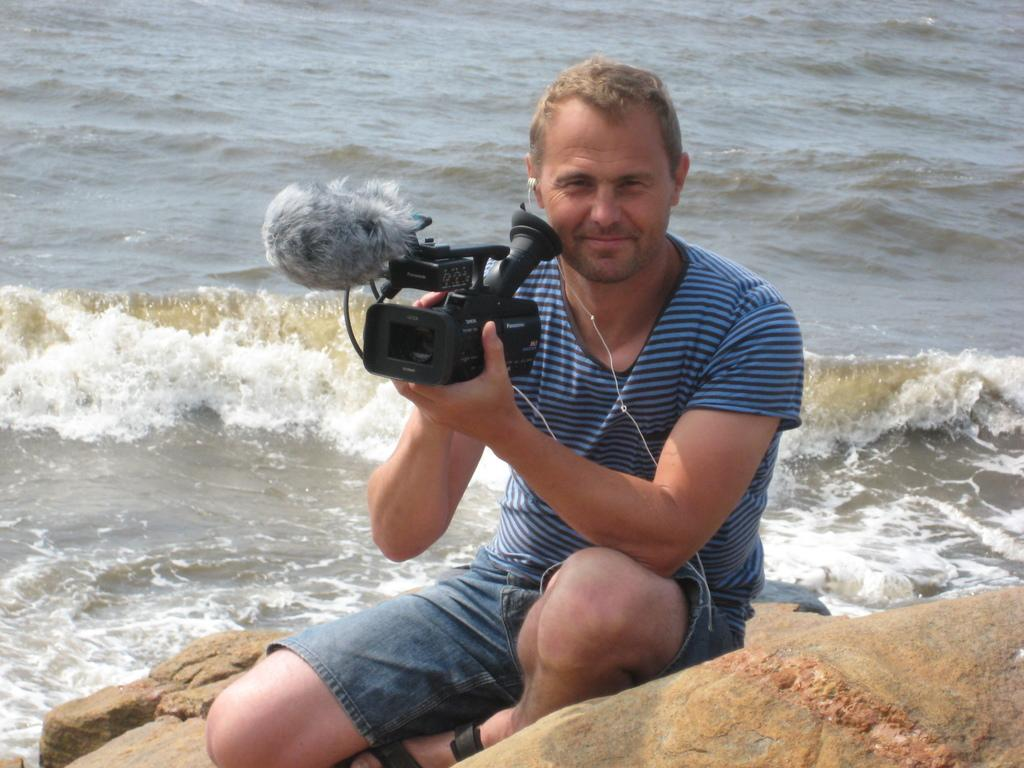What is the person in the image doing? The person is sitting on a rock in the image. What can be seen in the background of the image? There is water visible in the image. What is the person holding in the image? The person is holding a camera. What type of object is the person sitting on? There is a rock in the image. What type of ornament is hanging from the rock in the image? There is no ornament hanging from the rock in the image. Can you describe the basin that is present in the image? There is no basin present in the image. 